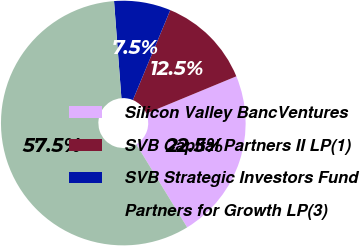Convert chart. <chart><loc_0><loc_0><loc_500><loc_500><pie_chart><fcel>Silicon Valley BancVentures<fcel>SVB Capital Partners II LP(1)<fcel>SVB Strategic Investors Fund<fcel>Partners for Growth LP(3)<nl><fcel>22.5%<fcel>12.49%<fcel>7.48%<fcel>57.54%<nl></chart> 